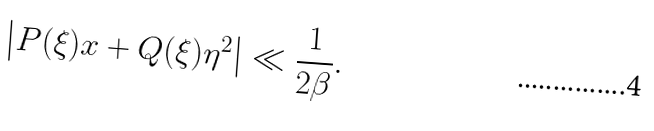<formula> <loc_0><loc_0><loc_500><loc_500>\left | P ( \xi ) x + Q ( \xi ) \eta ^ { 2 } \right | \ll \frac { 1 } { 2 \beta } .</formula> 